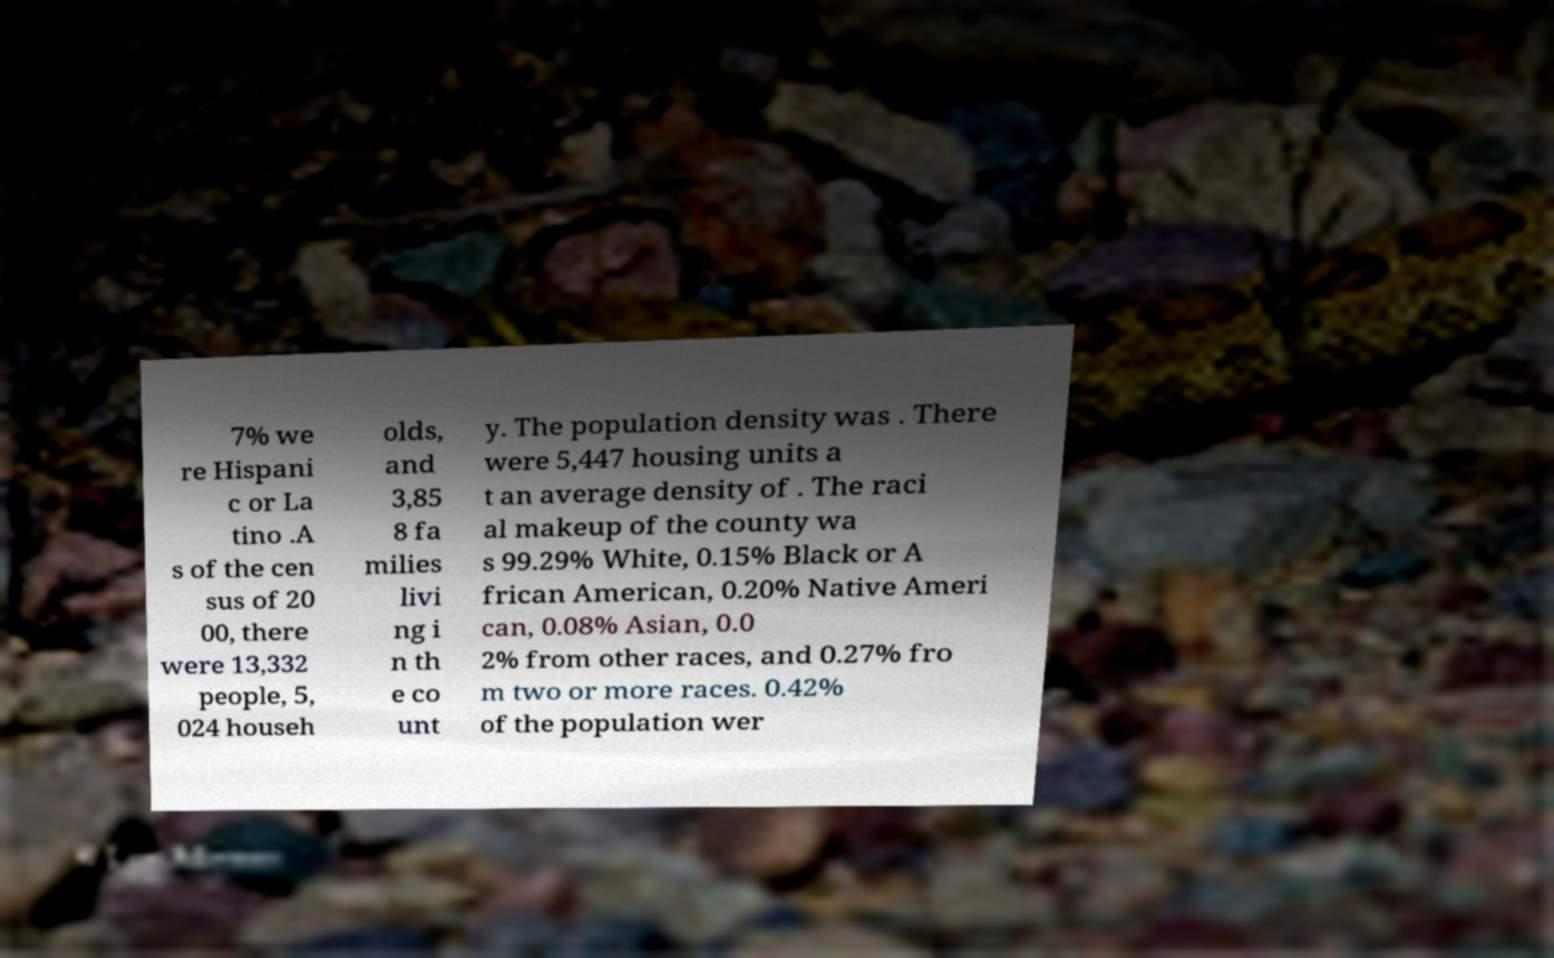Please read and relay the text visible in this image. What does it say? 7% we re Hispani c or La tino .A s of the cen sus of 20 00, there were 13,332 people, 5, 024 househ olds, and 3,85 8 fa milies livi ng i n th e co unt y. The population density was . There were 5,447 housing units a t an average density of . The raci al makeup of the county wa s 99.29% White, 0.15% Black or A frican American, 0.20% Native Ameri can, 0.08% Asian, 0.0 2% from other races, and 0.27% fro m two or more races. 0.42% of the population wer 